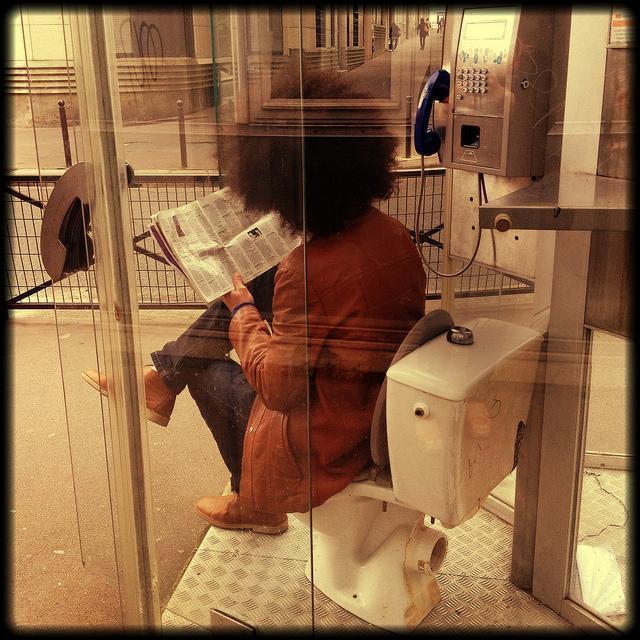How many boats are moving in the photo?
Give a very brief answer. 0. 